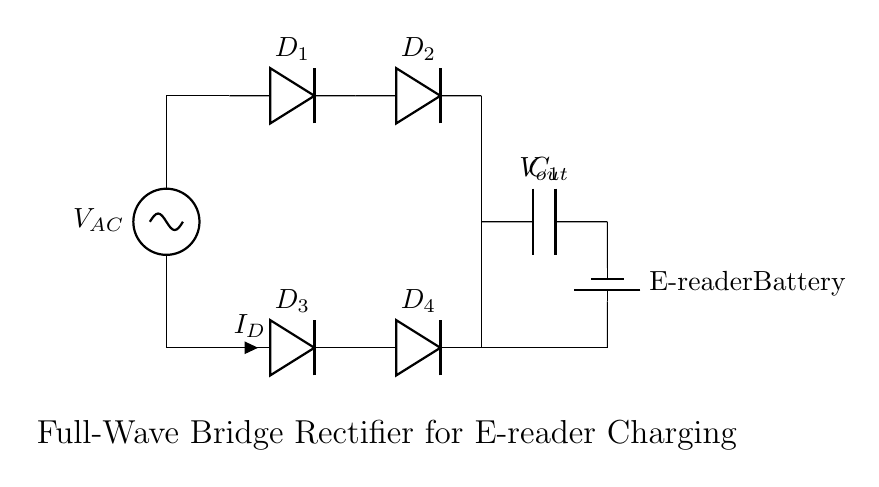What is the function of the smoothing capacitor? The smoothing capacitor, labeled C1, helps to reduce the fluctuations in the output voltage by storing charge and providing a more stable voltage to the load. This is essential for the continuous operation of the e-reader battery.
Answer: Stabilizing output voltage What type of rectifier is shown in the circuit? The circuit depicted is a full-wave bridge rectifier, as indicated by the arrangement of the four diodes which allows current to pass through both halves of the AC waveform. This configuration ensures that the output is always in one polarity.
Answer: Full-wave bridge rectifier How many diodes are used in the circuit? The circuit includes four diodes (D1, D2, D3, and D4) that make up the bridge rectifier configuration, allowing both halves of the AC waveform to be utilized for charging.
Answer: Four diodes What is the current labeled in the circuit? The current in the circuit is labeled as I_D, which indicates the current flowing through one of the diodes (D3) during operation. It represents the current output to the battery from the rectifier.
Answer: I_D What is the load connected to the output of the circuit? The load connected to the output is labeled as the e-reader battery, which indicates that this circuit is designed to charge a battery used in a portable e-reader device.
Answer: E-reader battery What happens to the output voltage during AC waveform peaks? During the peaks of the AC waveform, the diodes conduct, allowing current to flow and charging the capacitor, which results in higher voltage at the output, smoothing out to a more constant DC level.
Answer: Current flows; voltage rises 